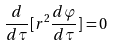<formula> <loc_0><loc_0><loc_500><loc_500>\frac { d } { d \tau } [ r ^ { 2 } \frac { d \varphi } { d \tau } ] = 0</formula> 